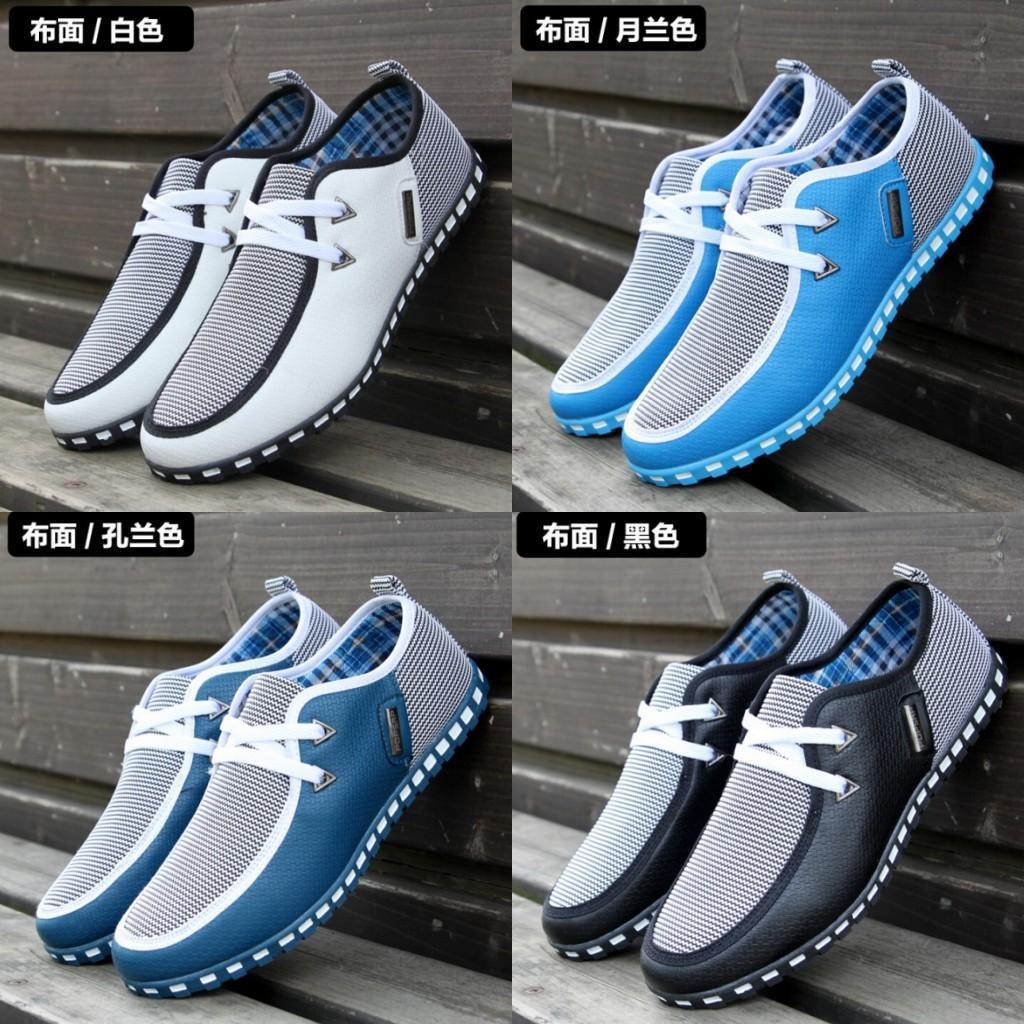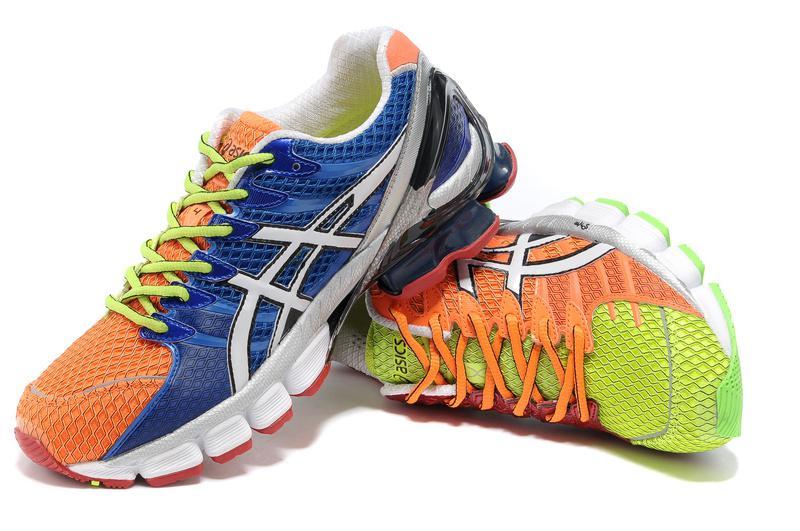The first image is the image on the left, the second image is the image on the right. Assess this claim about the two images: "A person is shown with at least one show in the image on the right.". Correct or not? Answer yes or no. No. The first image is the image on the left, the second image is the image on the right. Examine the images to the left and right. Is the description "A human foot is present in an image with at least one sneaker also present." accurate? Answer yes or no. No. 